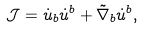Convert formula to latex. <formula><loc_0><loc_0><loc_500><loc_500>\mathcal { J } = \dot { u } _ { b } \dot { u } ^ { b } + \tilde { \nabla } _ { b } \dot { u } ^ { b } ,</formula> 